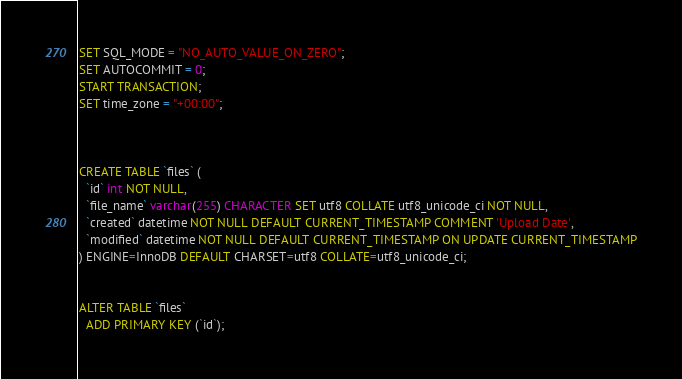Convert code to text. <code><loc_0><loc_0><loc_500><loc_500><_SQL_>SET SQL_MODE = "NO_AUTO_VALUE_ON_ZERO";
SET AUTOCOMMIT = 0;
START TRANSACTION;
SET time_zone = "+00:00";



CREATE TABLE `files` (
  `id` int NOT NULL,
  `file_name` varchar(255) CHARACTER SET utf8 COLLATE utf8_unicode_ci NOT NULL,
  `created` datetime NOT NULL DEFAULT CURRENT_TIMESTAMP COMMENT 'Upload Date',
  `modified` datetime NOT NULL DEFAULT CURRENT_TIMESTAMP ON UPDATE CURRENT_TIMESTAMP
) ENGINE=InnoDB DEFAULT CHARSET=utf8 COLLATE=utf8_unicode_ci;


ALTER TABLE `files`
  ADD PRIMARY KEY (`id`);

</code> 